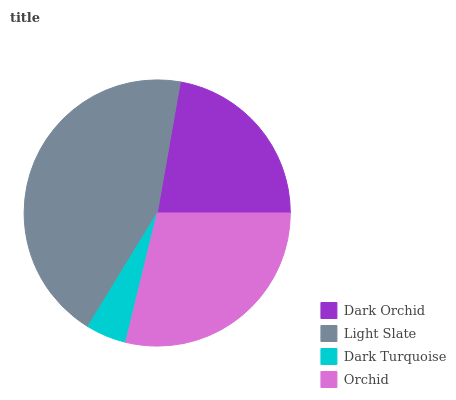Is Dark Turquoise the minimum?
Answer yes or no. Yes. Is Light Slate the maximum?
Answer yes or no. Yes. Is Light Slate the minimum?
Answer yes or no. No. Is Dark Turquoise the maximum?
Answer yes or no. No. Is Light Slate greater than Dark Turquoise?
Answer yes or no. Yes. Is Dark Turquoise less than Light Slate?
Answer yes or no. Yes. Is Dark Turquoise greater than Light Slate?
Answer yes or no. No. Is Light Slate less than Dark Turquoise?
Answer yes or no. No. Is Orchid the high median?
Answer yes or no. Yes. Is Dark Orchid the low median?
Answer yes or no. Yes. Is Light Slate the high median?
Answer yes or no. No. Is Orchid the low median?
Answer yes or no. No. 